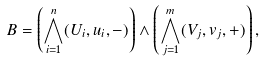Convert formula to latex. <formula><loc_0><loc_0><loc_500><loc_500>B = \left ( \bigwedge _ { i = 1 } ^ { n } ( U _ { i } , u _ { i } , - ) \right ) \wedge \left ( \bigwedge _ { j = 1 } ^ { m } ( V _ { j } , v _ { j } , + ) \right ) ,</formula> 